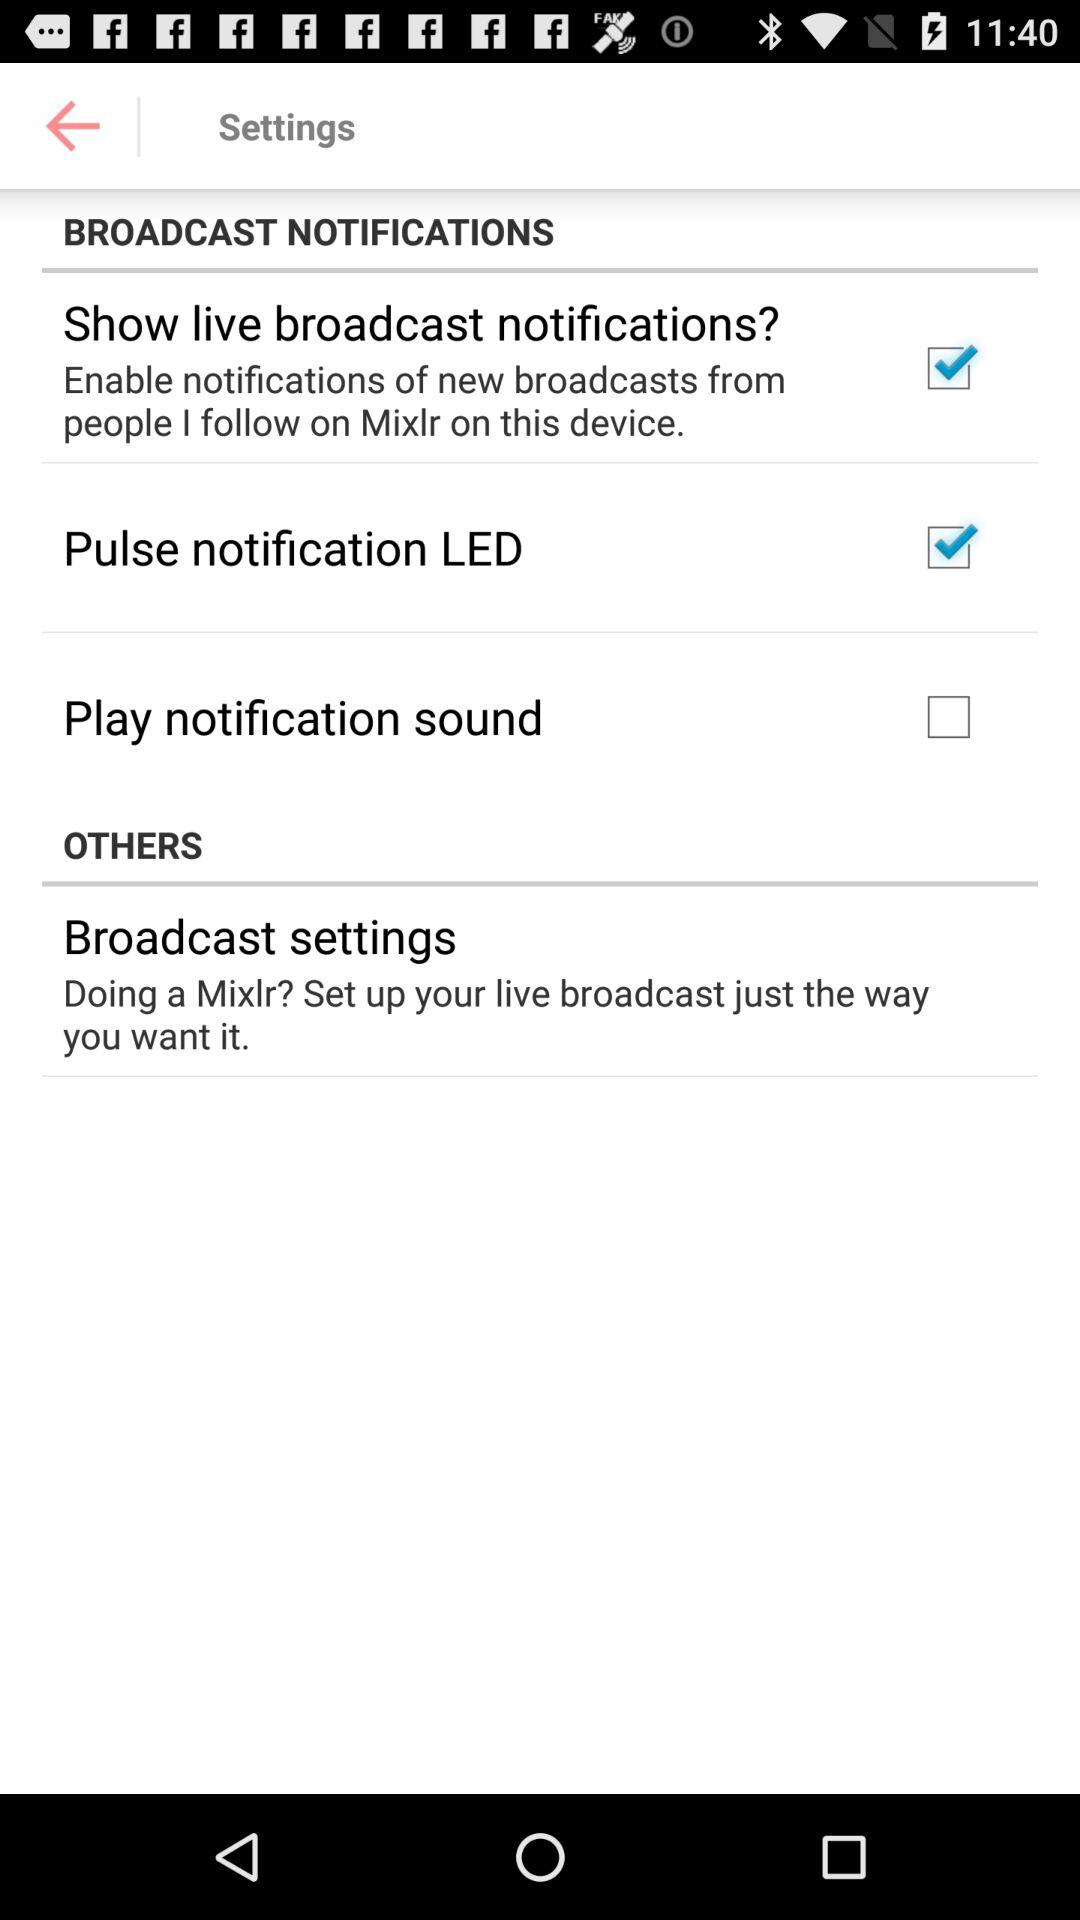What is the status of the "Play notification sound"? The status of the "Play notification sound" is "off". 